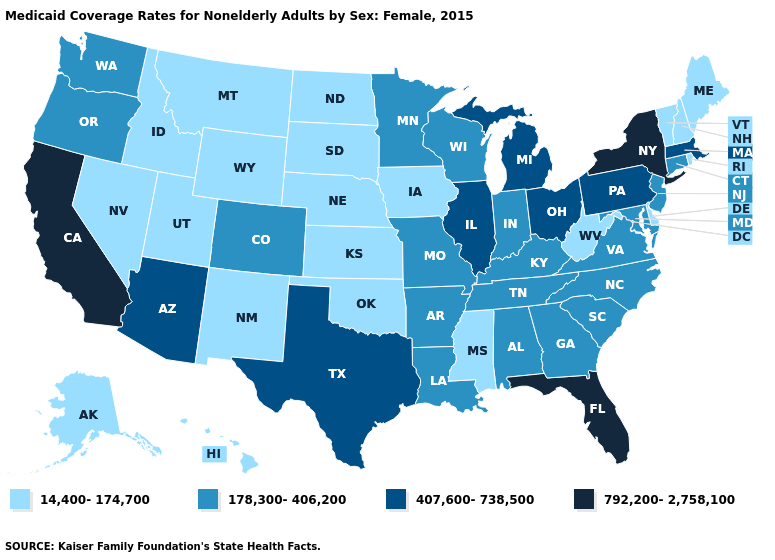Does Montana have the highest value in the USA?
Keep it brief. No. Name the states that have a value in the range 178,300-406,200?
Quick response, please. Alabama, Arkansas, Colorado, Connecticut, Georgia, Indiana, Kentucky, Louisiana, Maryland, Minnesota, Missouri, New Jersey, North Carolina, Oregon, South Carolina, Tennessee, Virginia, Washington, Wisconsin. What is the value of Indiana?
Keep it brief. 178,300-406,200. What is the value of Colorado?
Answer briefly. 178,300-406,200. What is the highest value in states that border Ohio?
Short answer required. 407,600-738,500. Name the states that have a value in the range 178,300-406,200?
Give a very brief answer. Alabama, Arkansas, Colorado, Connecticut, Georgia, Indiana, Kentucky, Louisiana, Maryland, Minnesota, Missouri, New Jersey, North Carolina, Oregon, South Carolina, Tennessee, Virginia, Washington, Wisconsin. What is the value of Kansas?
Write a very short answer. 14,400-174,700. Among the states that border New Hampshire , does Massachusetts have the highest value?
Be succinct. Yes. What is the lowest value in states that border Tennessee?
Concise answer only. 14,400-174,700. What is the value of Wisconsin?
Be succinct. 178,300-406,200. What is the value of Iowa?
Short answer required. 14,400-174,700. Which states have the highest value in the USA?
Write a very short answer. California, Florida, New York. What is the value of Maryland?
Concise answer only. 178,300-406,200. Among the states that border Virginia , does West Virginia have the lowest value?
Short answer required. Yes. What is the value of Arizona?
Quick response, please. 407,600-738,500. 